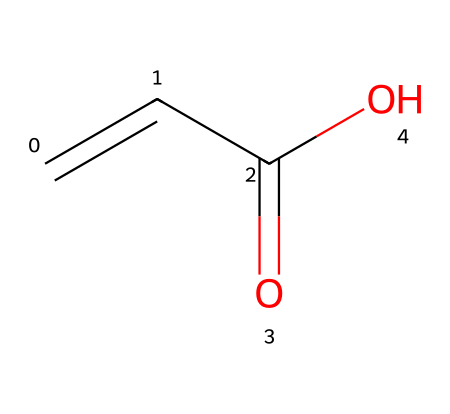What is the molecular formula of this chemical? The SMILES representation C=CC(=O)O indicates that the molecule contains one carbon-carbon double bond, one carbonyl group, and one hydroxyl group. By counting the atoms, we find there are four carbons (C), six hydrogens (H), and two oxygens (O), giving us the molecular formula C4H6O2.
Answer: C4H6O2 How many double bonds are present in the chemical structure? In the SMILES notation, there is a C=C (double bond) and a C=O (carbonyl double bond). Therefore, there are two double bonds present in this chemical structure.
Answer: two What functional groups are present in this chemical? The SMILES notation shows a carboxylic acid group (C(=O)O) and an alkene group (C=C) as part of the structure. These indicate that the functional groups present are a carboxylic acid and an alkene.
Answer: carboxylic acid and alkene How does the presence of the carboxylic acid group affect its properties? The carboxylic acid group (C(=O)O) is polar, allowing for hydrogen bonding, which increases solubility in water and contributes to acidity. These properties are critical for the performance of materials like photoresists.
Answer: increases solubility and acidity What is the role of acrylic acid in photoresists? Acrylic acid serves as a building block for polymers used in photoresists, providing functionality that allows for chemical changes upon exposure to light, leading to pattern development.
Answer: building block for polymers 